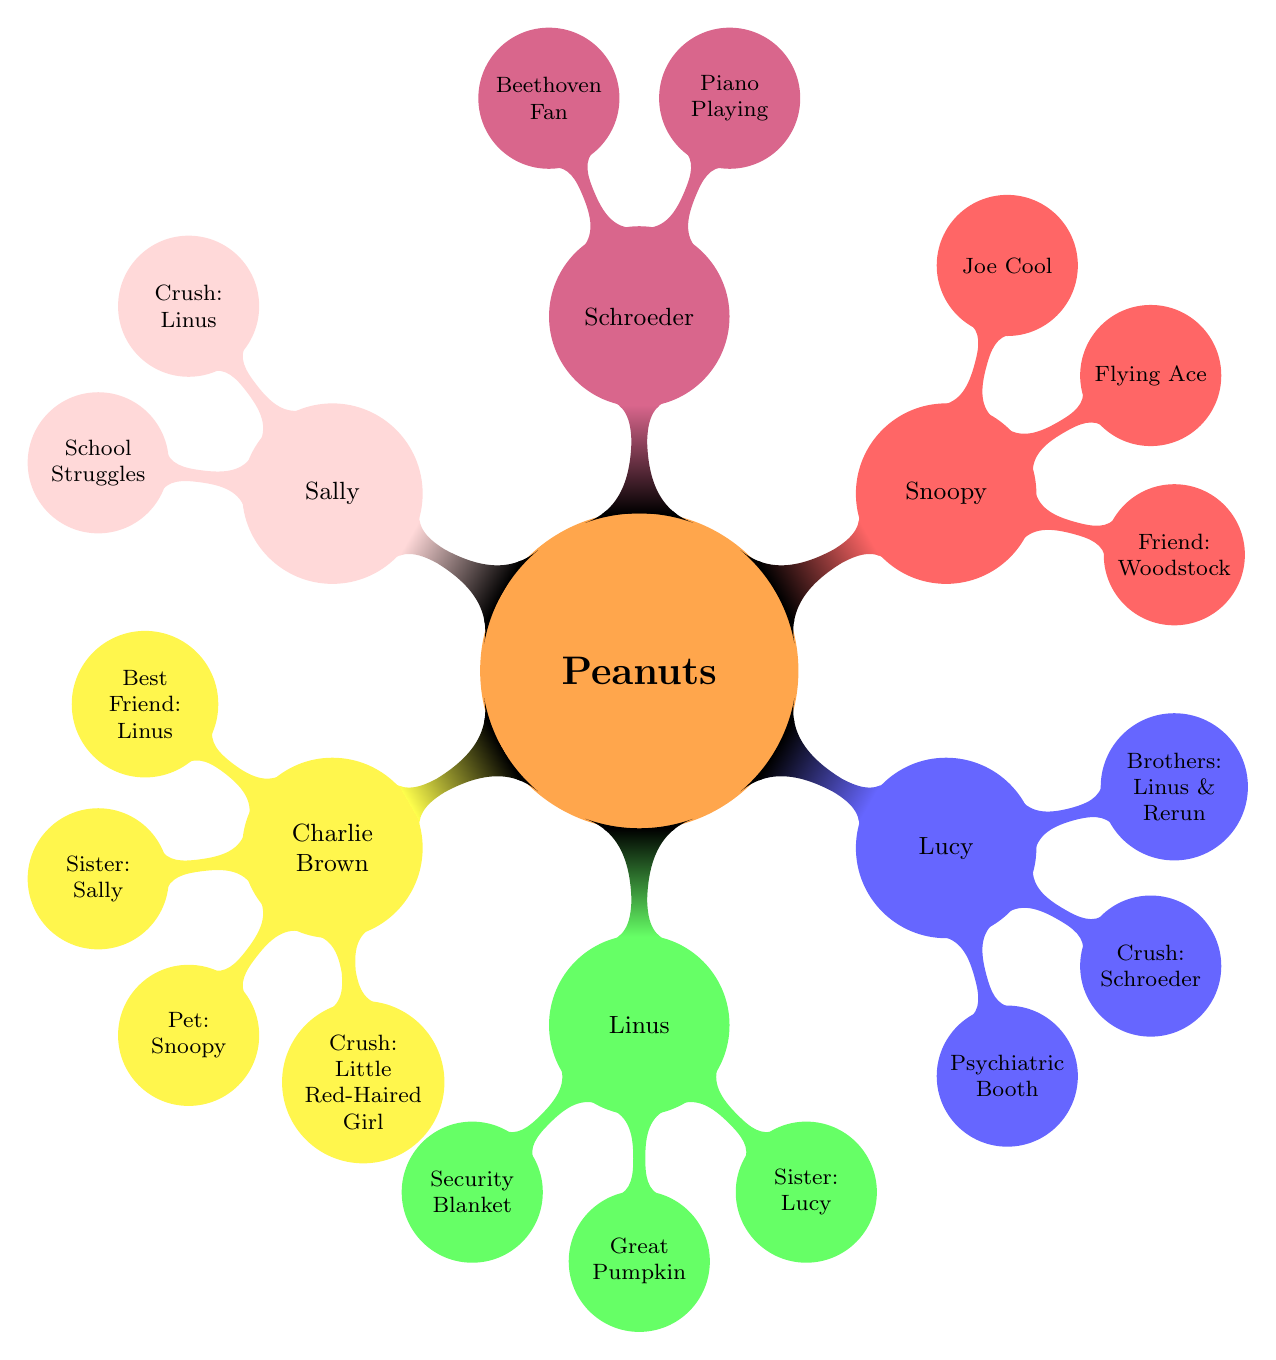What is Charlie Brown's crush? The diagram lists Charlie Brown's crush as the "Little Red-Haired Girl", which is shown directly under his node.
Answer: Little Red-Haired Girl How many siblings does Lucy Van Pelt have? The diagram indicates that Lucy has two brothers: Linus and Rerun, which sums up to two siblings shown under her node.
Answer: 2 Who is Snoopy's friend? Based on the diagram, Snoopy's friend is identified as "Woodstock", which is a direct connection under Snoopy's node.
Answer: Woodstock What unique item does Linus carry? Linus is depicted with the "Security Blanket", which is a specific characteristic listed under his node in the diagram.
Answer: Security Blanket Which character has a crush on Schroeder? Referring to the diagram, Lucy has a crush on Schroeder, as explicitly stated under Lucy's node.
Answer: Lucy Van Pelt Which character struggles in school? The diagram shows that Sally has "School Struggles," which is mentioned directly under her node.
Answer: Sally Brown What are the alter egos of Snoopy? Snoopy's alter egos, specified in the diagram, are "World War I Flying Ace" and "Joe Cool," located as details under Snoopy’s node.
Answer: World War I Flying Ace, Joe Cool What is the relationship between Charlie Brown and Sally? In the diagram, it states that Sally is Charlie Brown's sister, establishing their familial relation under Charlie Brown’s node.
Answer: Sister How many crushes does Schroeder have mentioned in the diagram? Schroeder is shown to have two crushes: "Beethoven" and "Lucy Van Pelt", indicated as two separate points under his node.
Answer: 2 